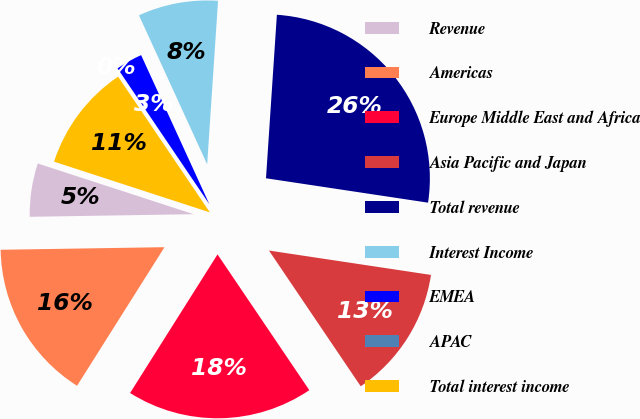<chart> <loc_0><loc_0><loc_500><loc_500><pie_chart><fcel>Revenue<fcel>Americas<fcel>Europe Middle East and Africa<fcel>Asia Pacific and Japan<fcel>Total revenue<fcel>Interest Income<fcel>EMEA<fcel>APAC<fcel>Total interest income<nl><fcel>5.26%<fcel>15.79%<fcel>18.42%<fcel>13.16%<fcel>26.32%<fcel>7.89%<fcel>2.63%<fcel>0.0%<fcel>10.53%<nl></chart> 